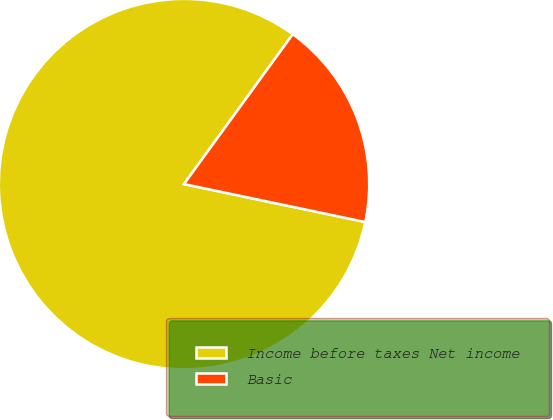Convert chart to OTSL. <chart><loc_0><loc_0><loc_500><loc_500><pie_chart><fcel>Income before taxes Net income<fcel>Basic<nl><fcel>81.71%<fcel>18.29%<nl></chart> 